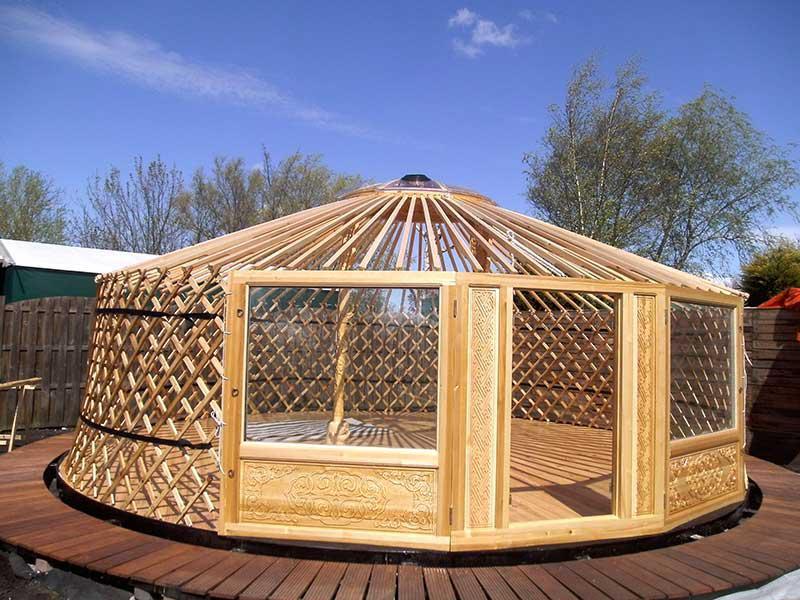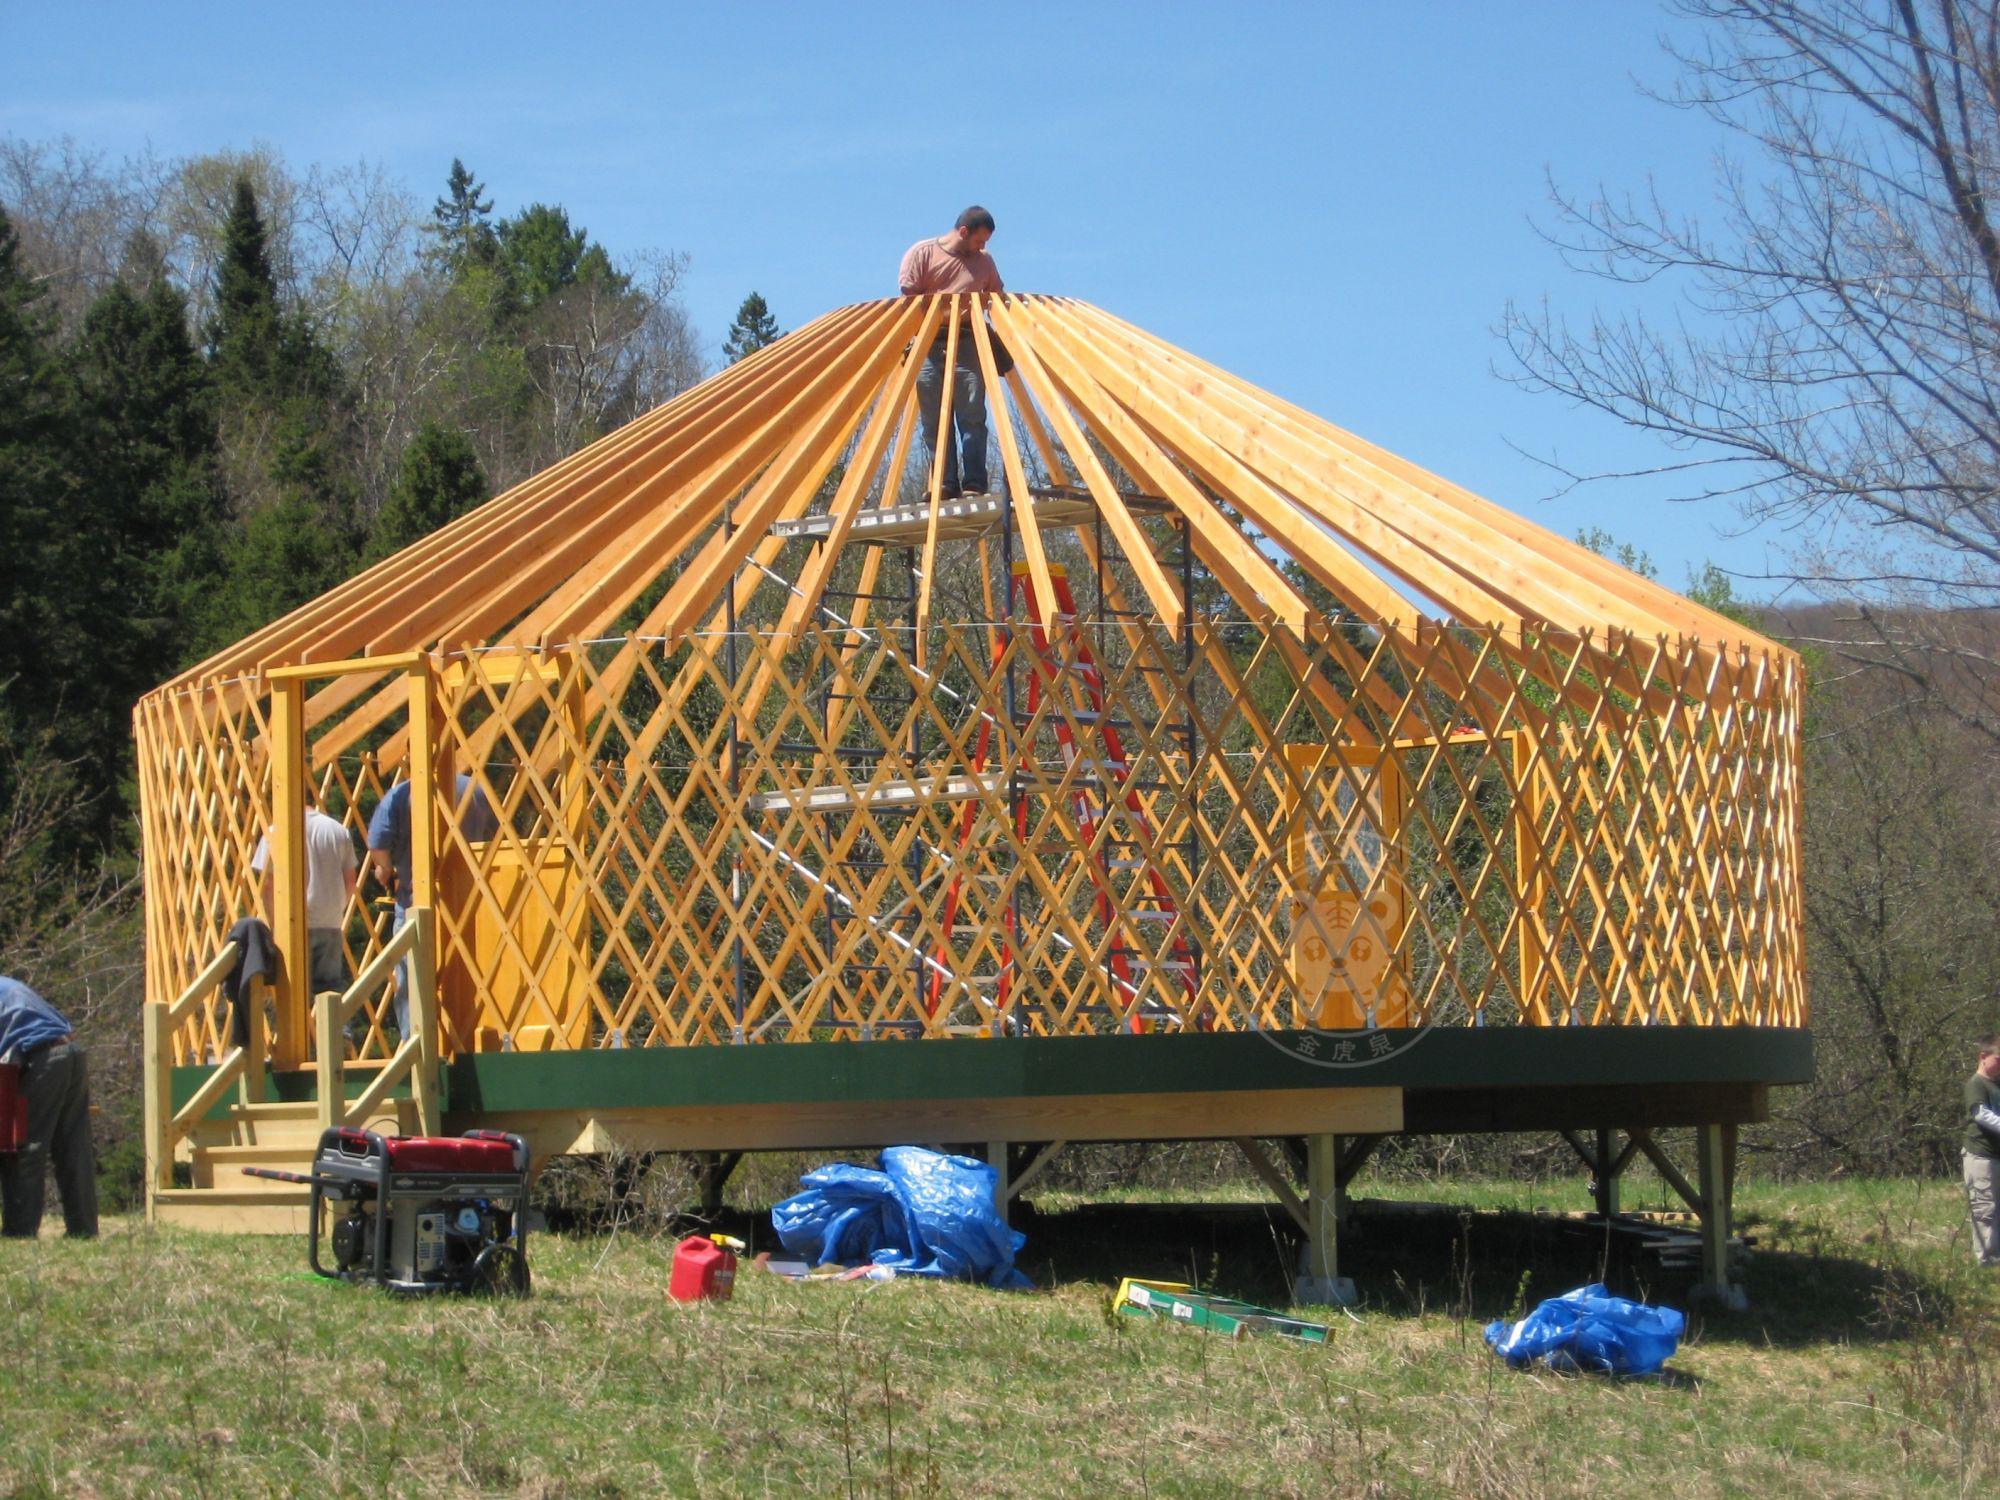The first image is the image on the left, the second image is the image on the right. For the images shown, is this caption "One image is the exterior of a wooden yurt, while the second image is a yurt interior that shows a kitchen area and ribbed wooden ceiling." true? Answer yes or no. No. 